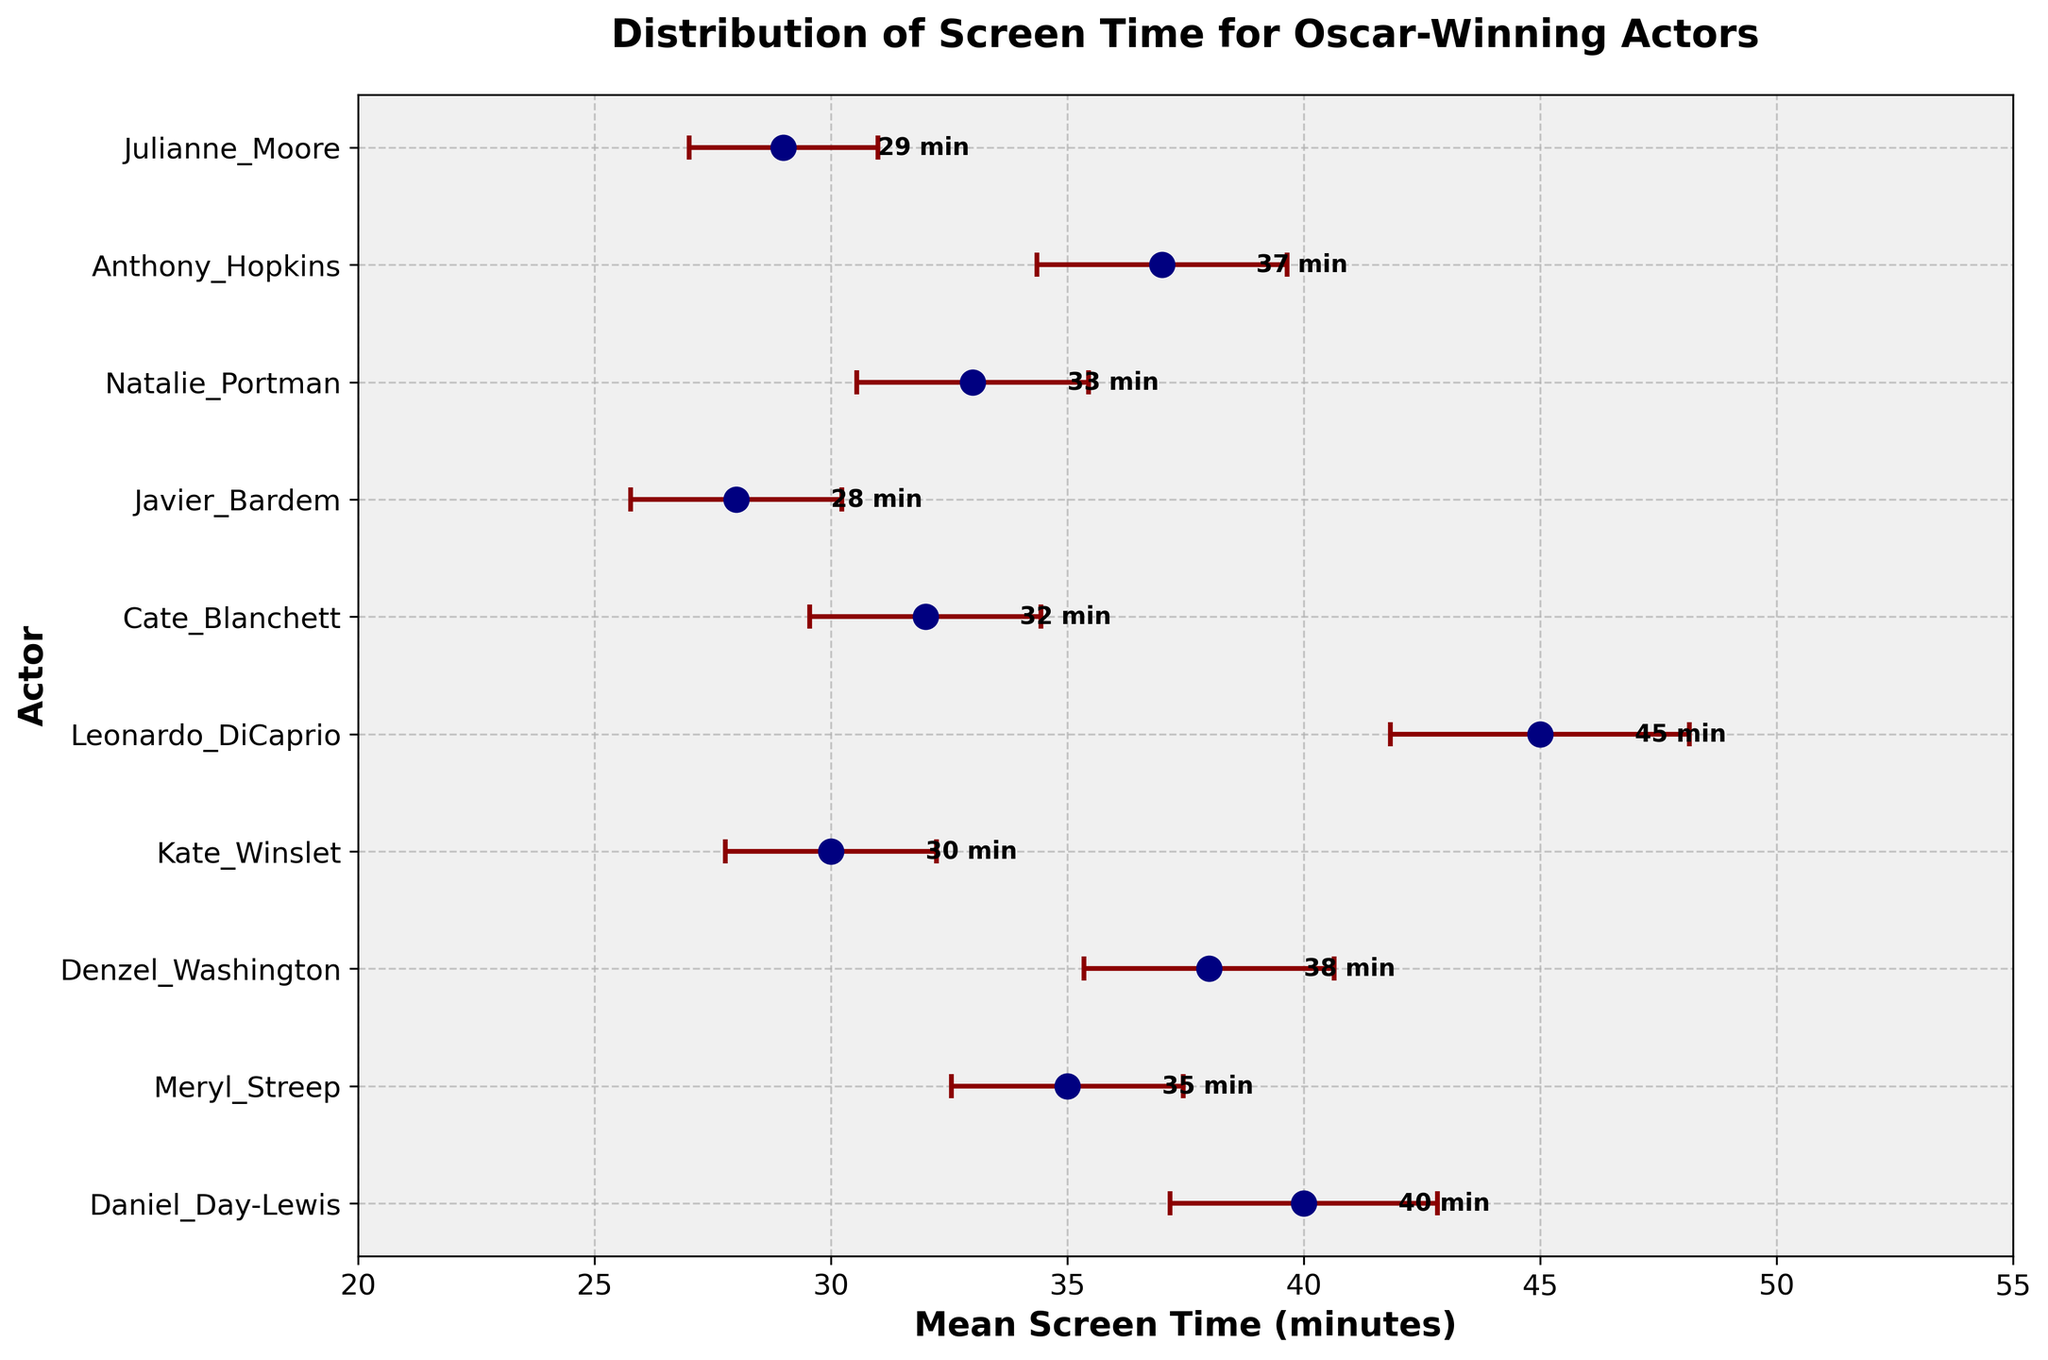Which actor has the highest mean screen time? The figure shows the distribution of screen time for different actors with error bars. By inspecting the highest mean value on the x-axis, we find that Leonardo DiCaprio has the highest mean screen time.
Answer: Leonardo DiCaprio What is the mean screen time for Meryl Streep? The figure lists the mean screen times next to each actor. Meryl Streep's mean screen time is around 35 minutes, as indicated by her data point.
Answer: 35 minutes Which actor has the smallest variance in their screen time? Variance is indicated by the size of the error bars. Julianne Moore has the smallest error bars, suggesting her variance in screen time is the smallest.
Answer: Julianne Moore How does the mean screen time of Anthony Hopkins compare to Daniel Day-Lewis? To compare mean screen times, look at the data points for both actors. Anthony Hopkins has a mean screen time of about 37 minutes, whereas Daniel Day-Lewis has 40 minutes. Therefore, Anthony Hopkins has a slightly lower mean screen time than Daniel Day-Lewis.
Answer: Anthony Hopkins has a lower mean screen time Who has the highest variance in their screen time? Variance is represented by the width of the error bars extending from the data points. Leonardo DiCaprio has the largest error bars, indicating he has the highest variance in screen time.
Answer: Leonardo DiCaprio Which actor has a mean screen time closer to 30 minutes? By inspecting the x-axis values, we see that Kate Winslet has a mean screen time of 30 minutes, which is exactly what the question asks.
Answer: Kate Winslet What is the range of the mean screen times shown in the figure? The range is found by subtracting the smallest mean screen time from the largest mean screen time. The smallest mean is Javier Bardem's 28 minutes and the largest is Leonardo DiCaprio's 45 minutes. Therefore, the range is 45 - 28 = 17 minutes.
Answer: 17 minutes Which actors have a mean screen time greater than 40 minutes? By identifying data points that are past 40 minutes on the x-axis, we see that Daniel Day-Lewis and Leonardo DiCaprio both have mean screen times greater than 40 minutes.
Answer: Daniel Day-Lewis and Leonardo DiCaprio Whose screen time has the least consistency across their career? Consistency is inversely related to variance; thus, the actor with the highest variance (Leonardo DiCaprio, identified by the largest error bars) has the least consistent screen time.
Answer: Leonardo DiCaprio What does the title of the figure suggest about the data? The title states "Distribution of Screen Time for Oscar-Winning Actors" with "Error Bars Indicating Variance Across Their Careers", which means the figure displays average screen times and the variability for various actors' career screen times.
Answer: It shows average screen times and their variability 